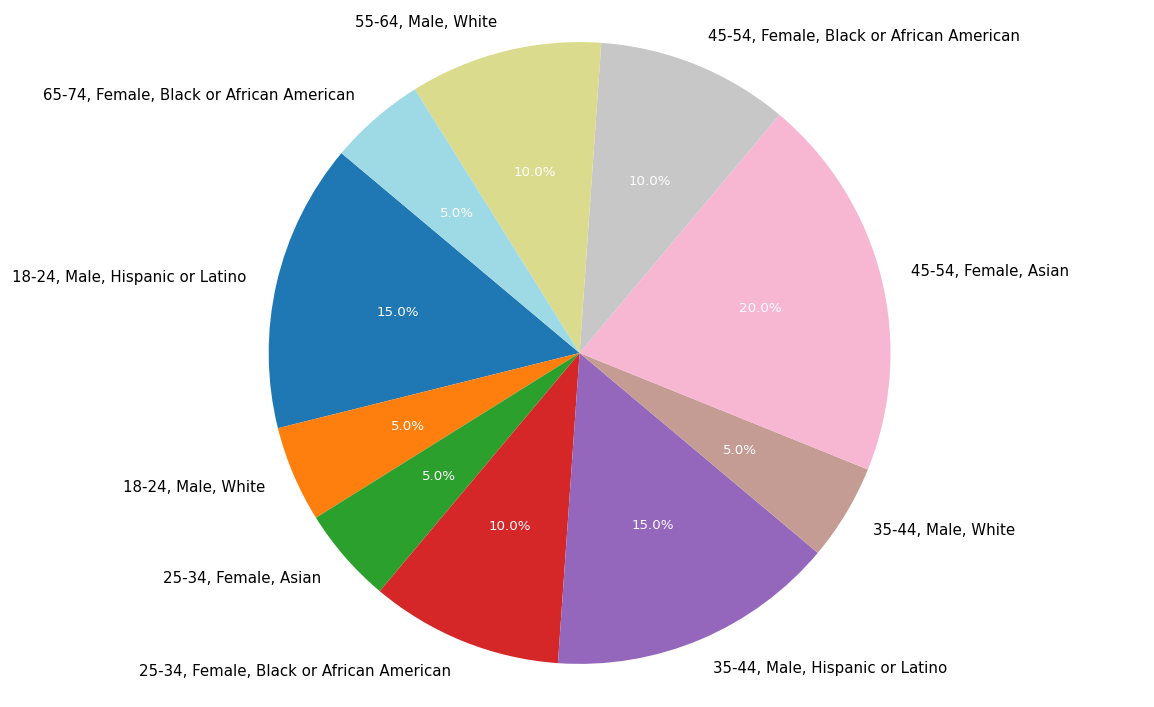Which age group has the highest participation percentage? The age group with the highest percentage is visually the largest slice in the pie chart. The segment labeled "45-54, Female, Asian" visually occupies the largest portion, indicating it has 20% participation.
Answer: 45-54 Which gender had more participation overall, male or female? To determine this, sum the percentages of male and female participants. Male participation: 5 + 15 + 10 + 15 + 5 = 50%; Female participation: 10 + 20 + 5 + 10 = 45%. Therefore, males had more participation.
Answer: Male What was the combined participation percentage for the "White" ethnicity across all age groups? Identify and sum the segments with "White" ethnicity. The relevant data points are "18-24, Male, White" (5%), "55-64, Male, White" (10%), and "35-44, Male, White" (5%). The combined participation is 5 + 10 + 5 = 20%.
Answer: 20% Which group had the smallest representation percentage? The smallest slice in the pie chart corresponds to the smallest percentage. The segment labeled "25-34, Female, Asian" occupies the smallest area, indicating it has 5% participation.
Answer: 25-34, Female, Asian What is the total percentage of participants from the "Black or African American" ethnicity? Sum the percentages for all segments labeled as "Black or African American." The relevant data points are "25-34, Female, Black or African American" (10%), "65-74, Female, Black or African American" (5%), and "45-54, Female, Black or African American" (10%). The combined total is 10 + 5 + 10 = 25%.
Answer: 25% Which age groups had equal percentages of participation? Compare the percentages of different age groups. Groups "18-24, Male, White" (5%) and "35-44, Male, White" (5%) have equal participation percentages. Also, "25-34, Female, Asian" (5%) and "65-74, Female, Black or African American" (5%) have equal participation.
Answer: 18-24 & 35-44, 25-34 & 65-74 Which ethnicity had the highest total percentage of participation across all age groups? Sum the percentages for each ethnicity. White: 5 + 10 + 5 = 20%, Black or African American: 10 + 5 + 10 = 25%, Hispanic or Latino: 15 + 15 = 30%, Asian: 20 + 5 = 25%. Hispanic or Latino has the highest total participation at 30%.
Answer: Hispanic or Latino 